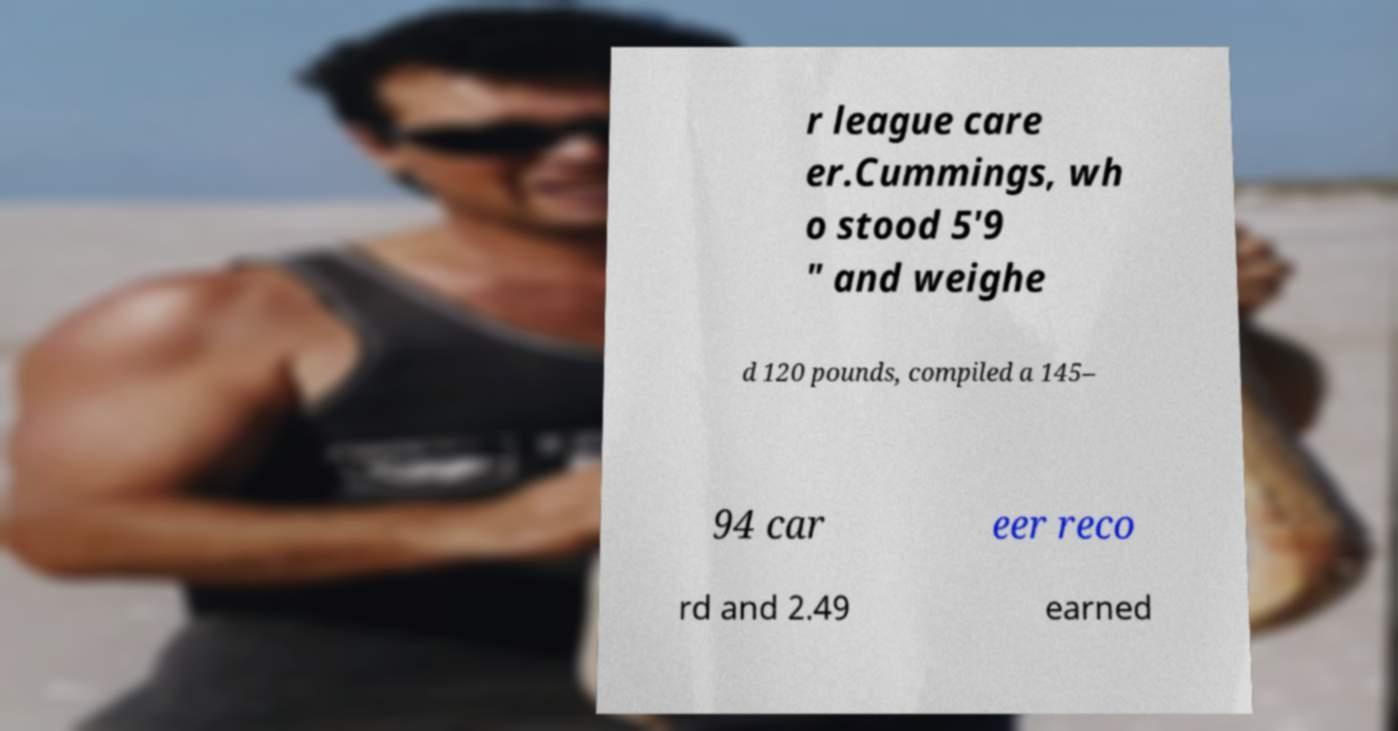Can you read and provide the text displayed in the image?This photo seems to have some interesting text. Can you extract and type it out for me? r league care er.Cummings, wh o stood 5'9 " and weighe d 120 pounds, compiled a 145– 94 car eer reco rd and 2.49 earned 